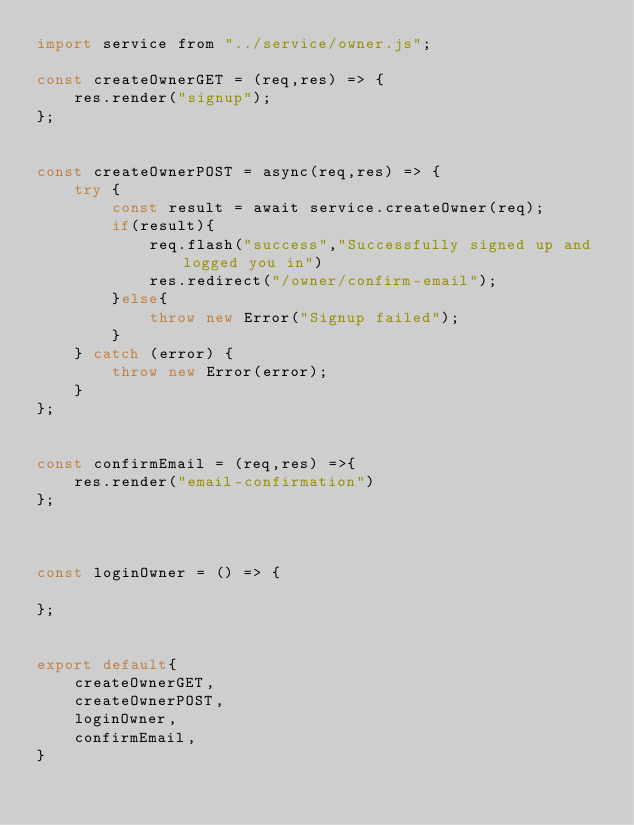<code> <loc_0><loc_0><loc_500><loc_500><_JavaScript_>import service from "../service/owner.js";

const createOwnerGET = (req,res) => {
    res.render("signup");
};


const createOwnerPOST = async(req,res) => {
    try {
        const result = await service.createOwner(req);
        if(result){
            req.flash("success","Successfully signed up and logged you in")
            res.redirect("/owner/confirm-email");
        }else{
            throw new Error("Signup failed");
        }
    } catch (error) {
        throw new Error(error);
    }
};


const confirmEmail = (req,res) =>{
    res.render("email-confirmation")
};



const loginOwner = () => {

};


export default{
    createOwnerGET,
    createOwnerPOST,
    loginOwner,
    confirmEmail,
}</code> 